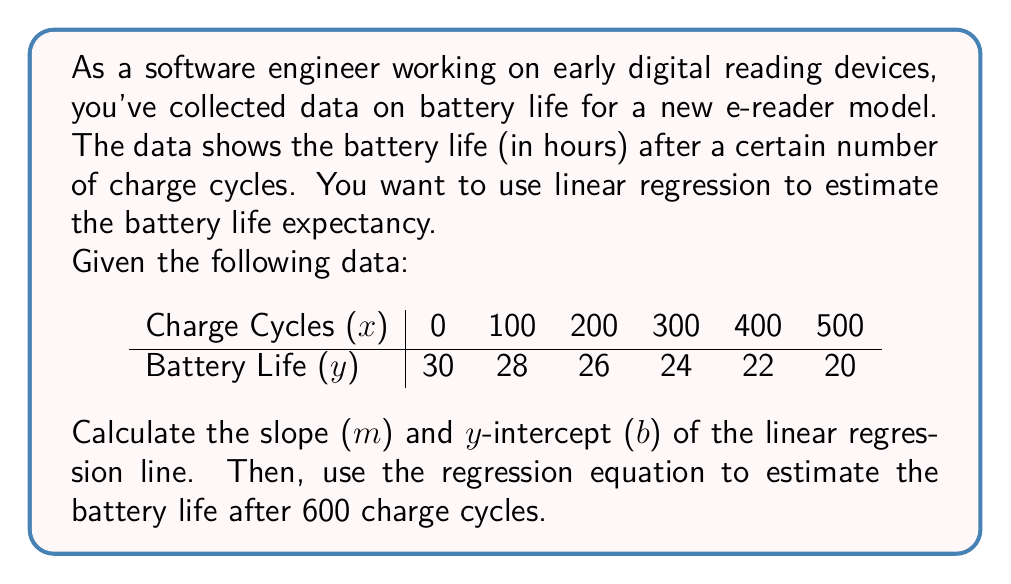Can you solve this math problem? To solve this problem, we'll use the linear regression formula:

$$ y = mx + b $$

Where m is the slope and b is the y-intercept.

Step 1: Calculate the means of x and y
$$ \bar{x} = \frac{\sum x}{n} = \frac{0 + 100 + 200 + 300 + 400 + 500}{6} = 250 $$
$$ \bar{y} = \frac{\sum y}{n} = \frac{30 + 28 + 26 + 24 + 22 + 20}{6} = 25 $$

Step 2: Calculate the slope (m)
$$ m = \frac{\sum (x - \bar{x})(y - \bar{y})}{\sum (x - \bar{x})^2} $$

Create a table to calculate the numerator and denominator:

| x   | y   | x - x̄ | y - ȳ | (x - x̄)(y - ȳ) | (x - x̄)² |
|-----|-----|-------|-------|-----------------|-----------|
| 0   | 30  | -250  | 5     | -1250           | 62500     |
| 100 | 28  | -150  | 3     | -450            | 22500     |
| 200 | 26  | -50   | 1     | -50             | 2500      |
| 300 | 24  | 50    | -1    | -50             | 2500      |
| 400 | 22  | 150   | -3    | -450            | 22500     |
| 500 | 20  | 250   | -5    | -1250           | 62500     |

Sum of (x - x̄)(y - ȳ) = -3500
Sum of (x - x̄)² = 175000

$$ m = \frac{-3500}{175000} = -0.02 $$

Step 3: Calculate the y-intercept (b)
$$ b = \bar{y} - m\bar{x} = 25 - (-0.02 * 250) = 30 $$

Step 4: Write the regression equation
$$ y = -0.02x + 30 $$

Step 5: Estimate battery life after 600 charge cycles
$$ y = -0.02(600) + 30 = 18 $$
Answer: The linear regression equation is $y = -0.02x + 30$, where x is the number of charge cycles and y is the battery life in hours. The estimated battery life after 600 charge cycles is 18 hours. 